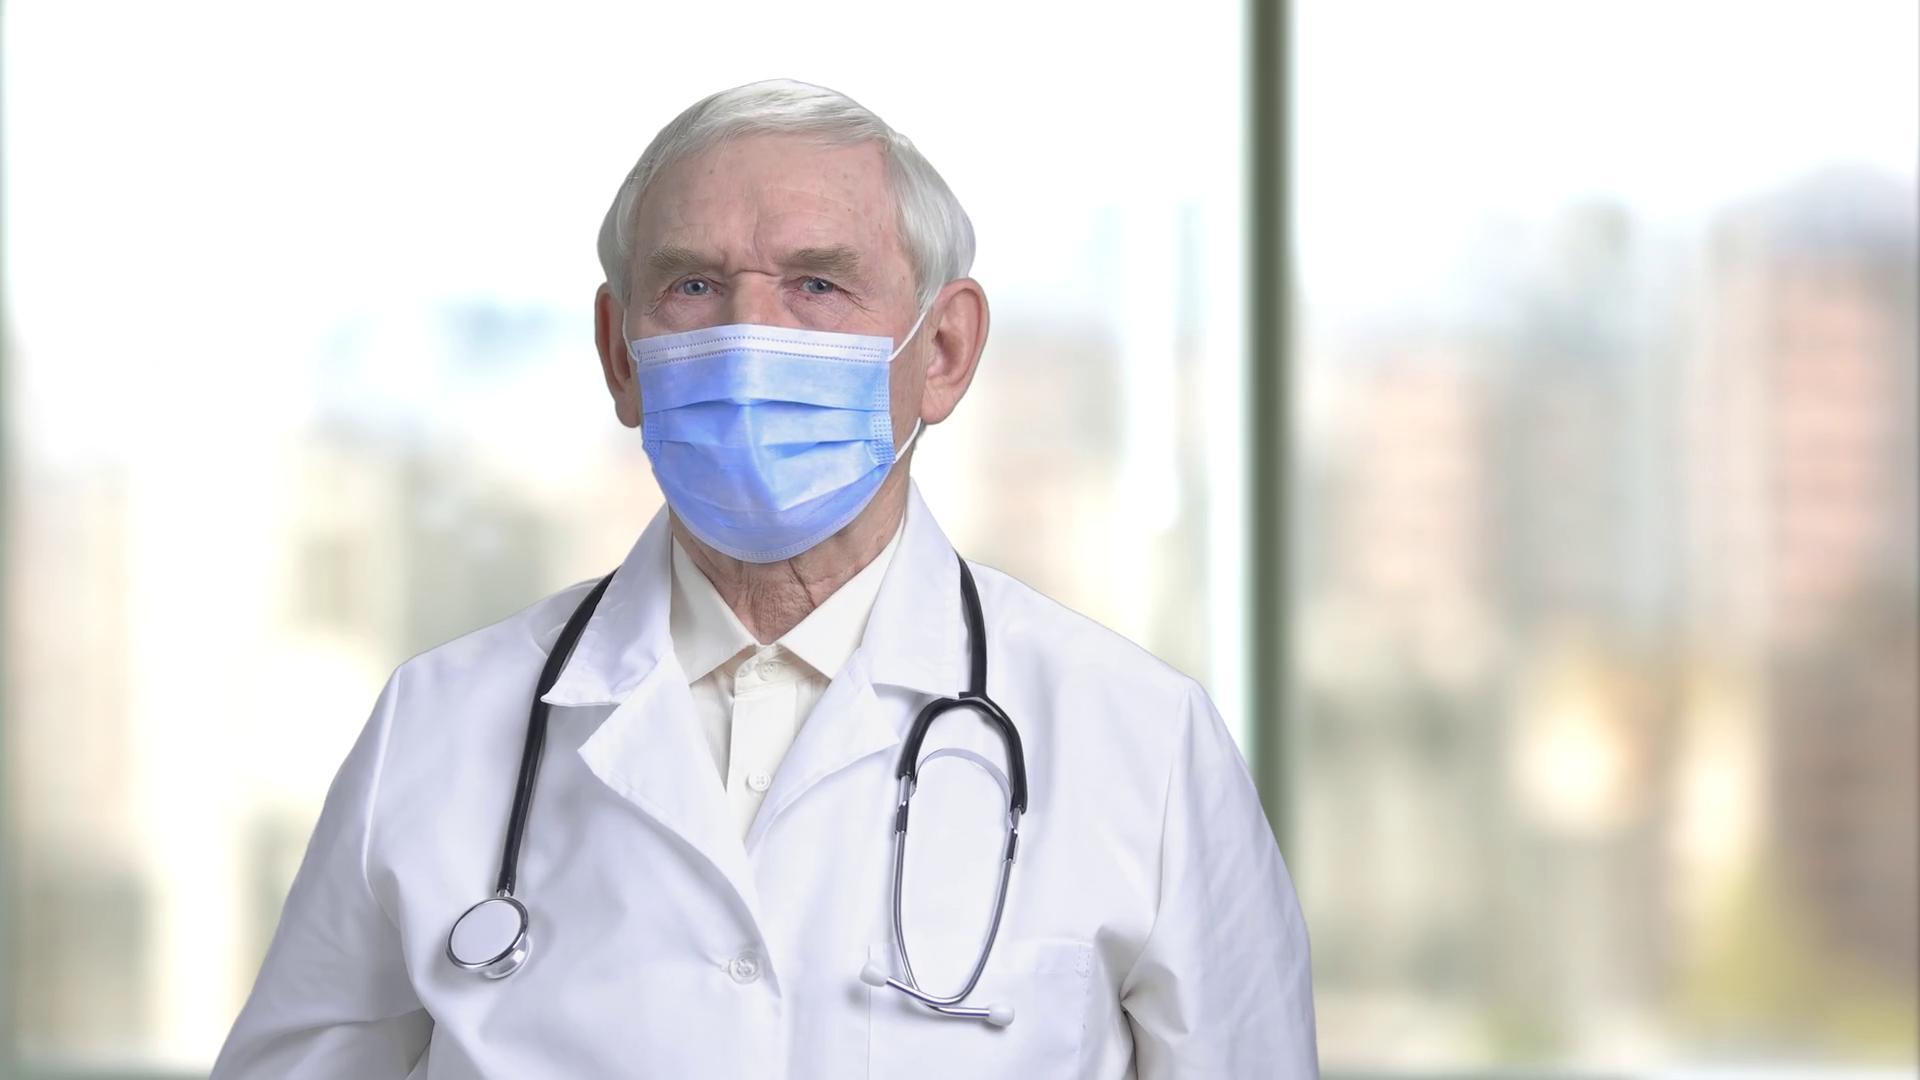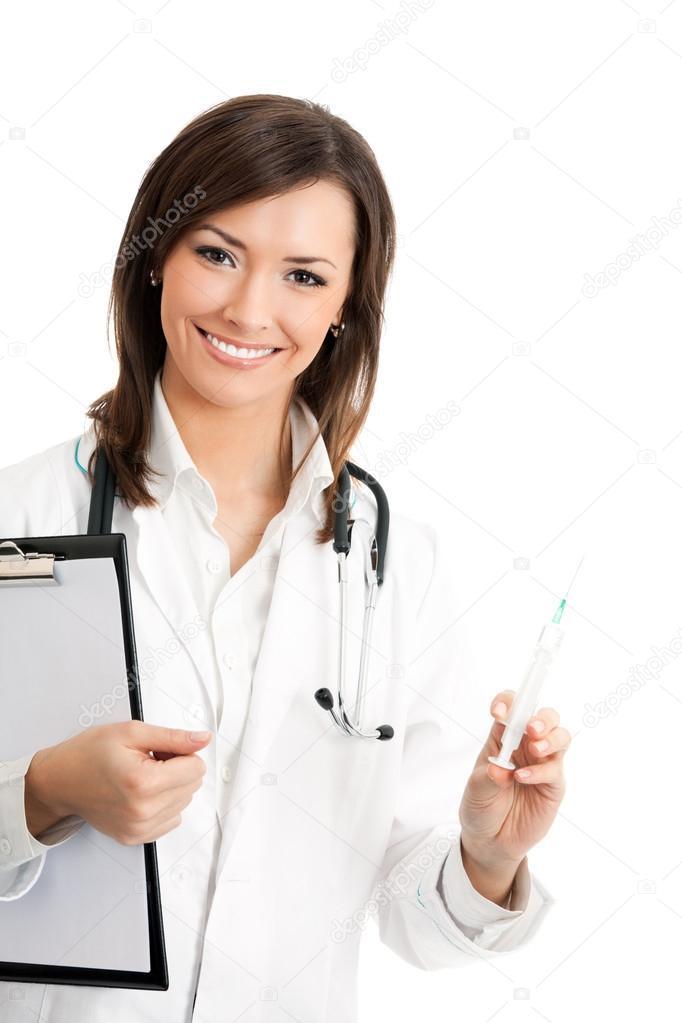The first image is the image on the left, the second image is the image on the right. Assess this claim about the two images: "A doctor is looking at a syringe.". Correct or not? Answer yes or no. No. The first image is the image on the left, the second image is the image on the right. Assess this claim about the two images: "A woman is wearing a stethoscope in the image on the right.". Correct or not? Answer yes or no. Yes. 